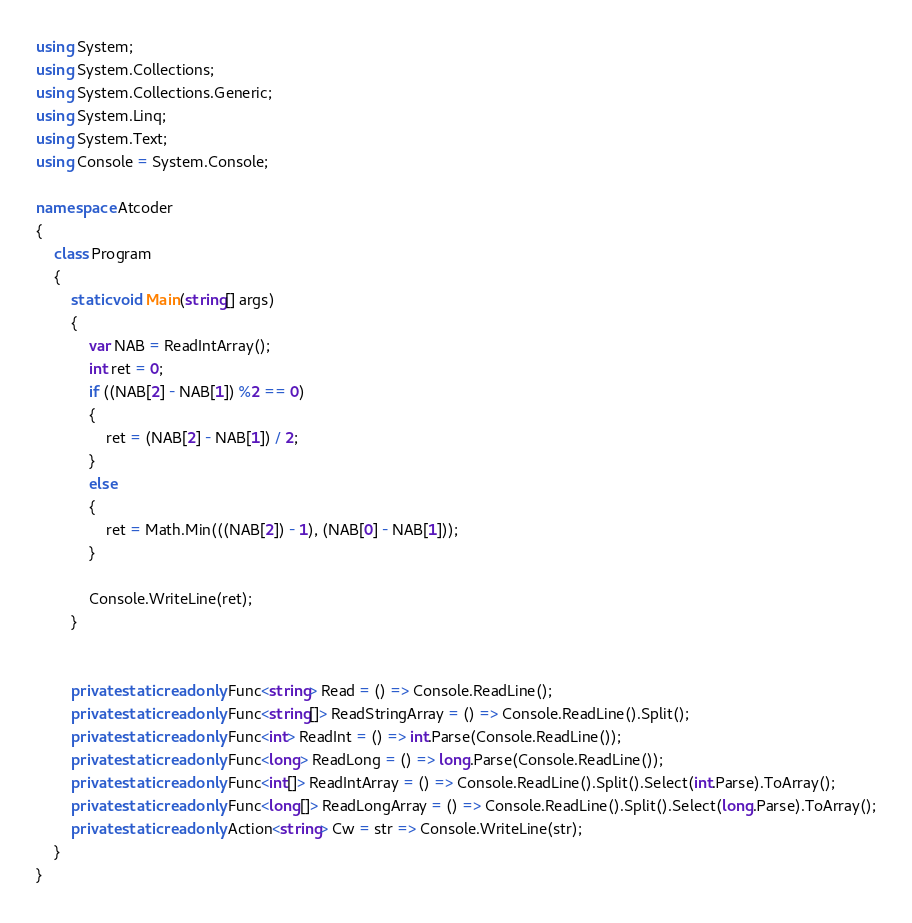Convert code to text. <code><loc_0><loc_0><loc_500><loc_500><_C#_>using System;
using System.Collections;
using System.Collections.Generic;
using System.Linq;
using System.Text;
using Console = System.Console;

namespace Atcoder
{
    class Program
    {
        static void Main(string[] args)
        {
            var NAB = ReadIntArray();
            int ret = 0;
            if ((NAB[2] - NAB[1]) %2 == 0)
            {
                ret = (NAB[2] - NAB[1]) / 2;
            }
            else
            {
                ret = Math.Min(((NAB[2]) - 1), (NAB[0] - NAB[1]));
            }

            Console.WriteLine(ret);
        }


        private static readonly Func<string> Read = () => Console.ReadLine();
        private static readonly Func<string[]> ReadStringArray = () => Console.ReadLine().Split();
        private static readonly Func<int> ReadInt = () => int.Parse(Console.ReadLine());
        private static readonly Func<long> ReadLong = () => long.Parse(Console.ReadLine());
        private static readonly Func<int[]> ReadIntArray = () => Console.ReadLine().Split().Select(int.Parse).ToArray();
        private static readonly Func<long[]> ReadLongArray = () => Console.ReadLine().Split().Select(long.Parse).ToArray();
        private static readonly Action<string> Cw = str => Console.WriteLine(str);
    }
}</code> 